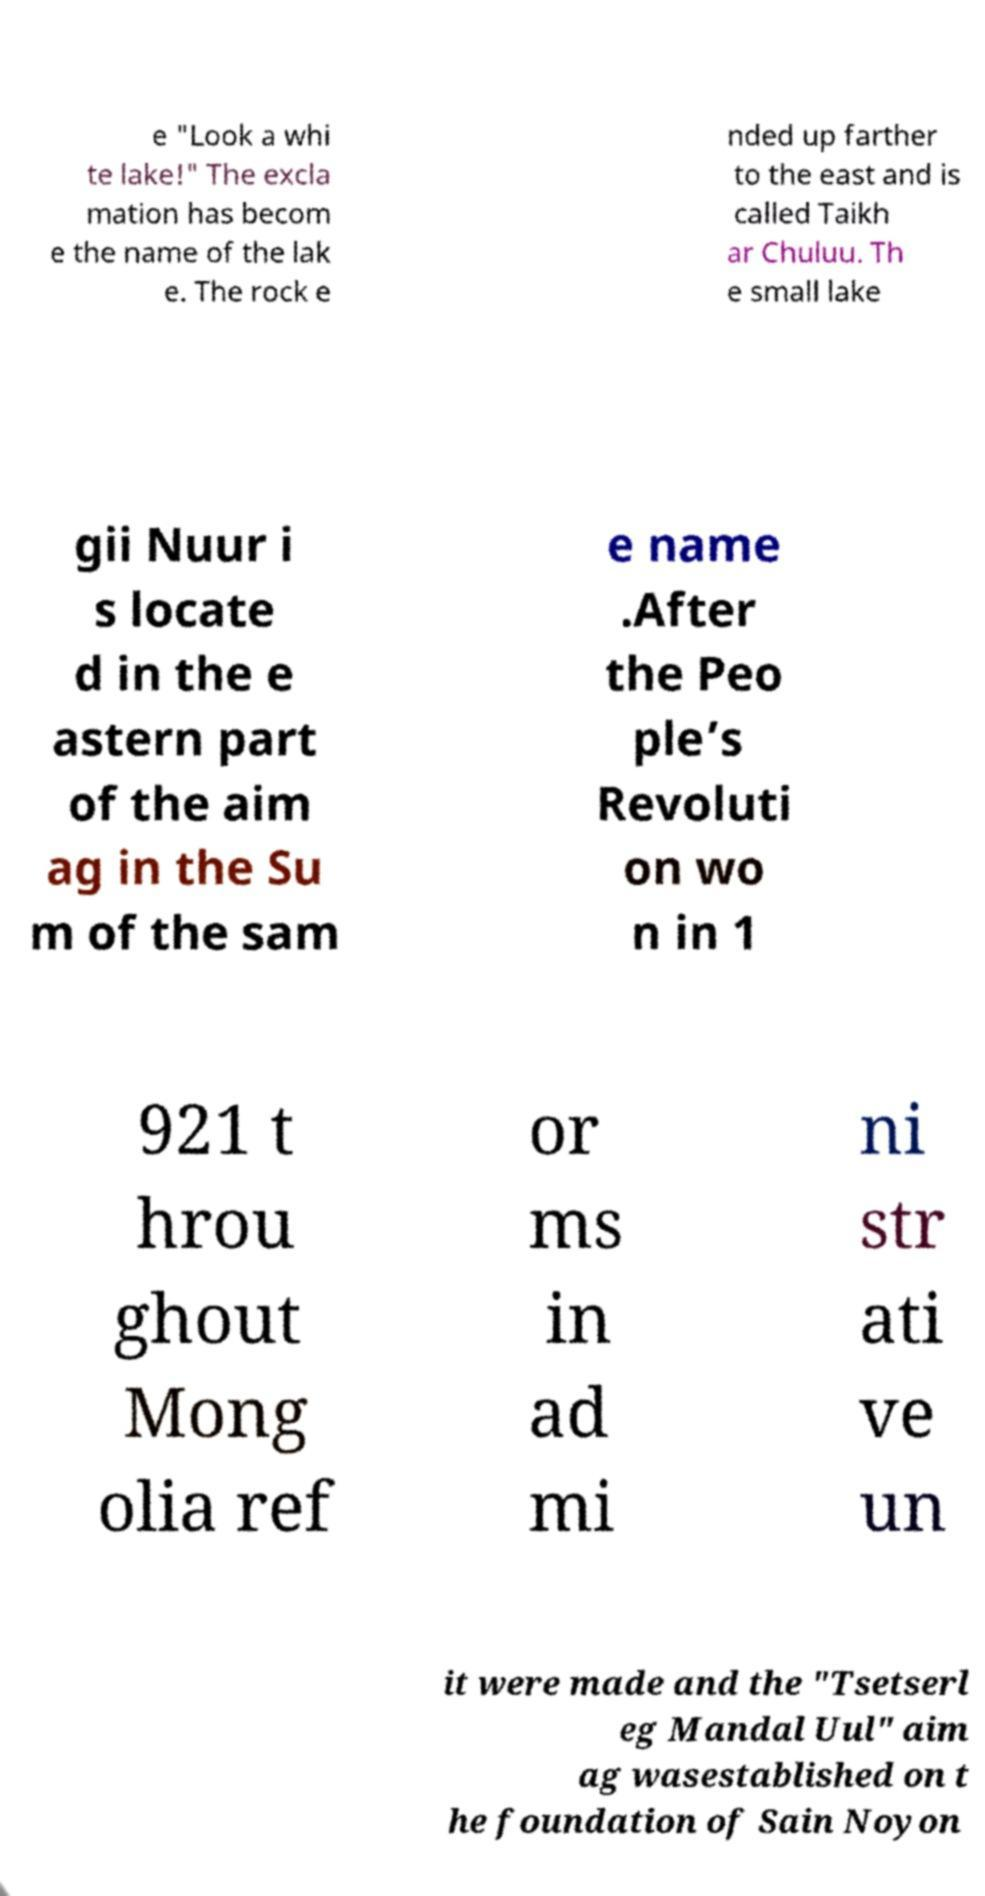For documentation purposes, I need the text within this image transcribed. Could you provide that? e "Look a whi te lake!" The excla mation has becom e the name of the lak e. The rock e nded up farther to the east and is called Taikh ar Chuluu. Th e small lake gii Nuur i s locate d in the e astern part of the aim ag in the Su m of the sam e name .After the Peo ple’s Revoluti on wo n in 1 921 t hrou ghout Mong olia ref or ms in ad mi ni str ati ve un it were made and the "Tsetserl eg Mandal Uul" aim ag wasestablished on t he foundation of Sain Noyon 